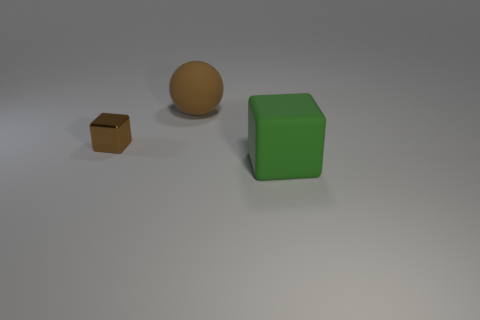Are there any big green matte things of the same shape as the metallic object?
Offer a terse response. Yes. The sphere that is the same size as the green rubber thing is what color?
Make the answer very short. Brown. There is a large object to the right of the object behind the metal thing; what is its color?
Offer a terse response. Green. Does the big matte thing in front of the big brown sphere have the same color as the metal cube?
Make the answer very short. No. What is the shape of the big thing that is behind the rubber object that is in front of the brown thing behind the tiny cube?
Make the answer very short. Sphere. There is a big rubber thing behind the large green rubber object; what number of brown objects are in front of it?
Ensure brevity in your answer.  1. Is the material of the large block the same as the small object?
Make the answer very short. No. There is a matte thing that is on the left side of the big object in front of the brown metallic object; what number of brown cubes are in front of it?
Provide a succinct answer. 1. What color is the big thing in front of the sphere?
Give a very brief answer. Green. There is a brown thing in front of the big ball behind the small brown cube; what shape is it?
Keep it short and to the point. Cube. 